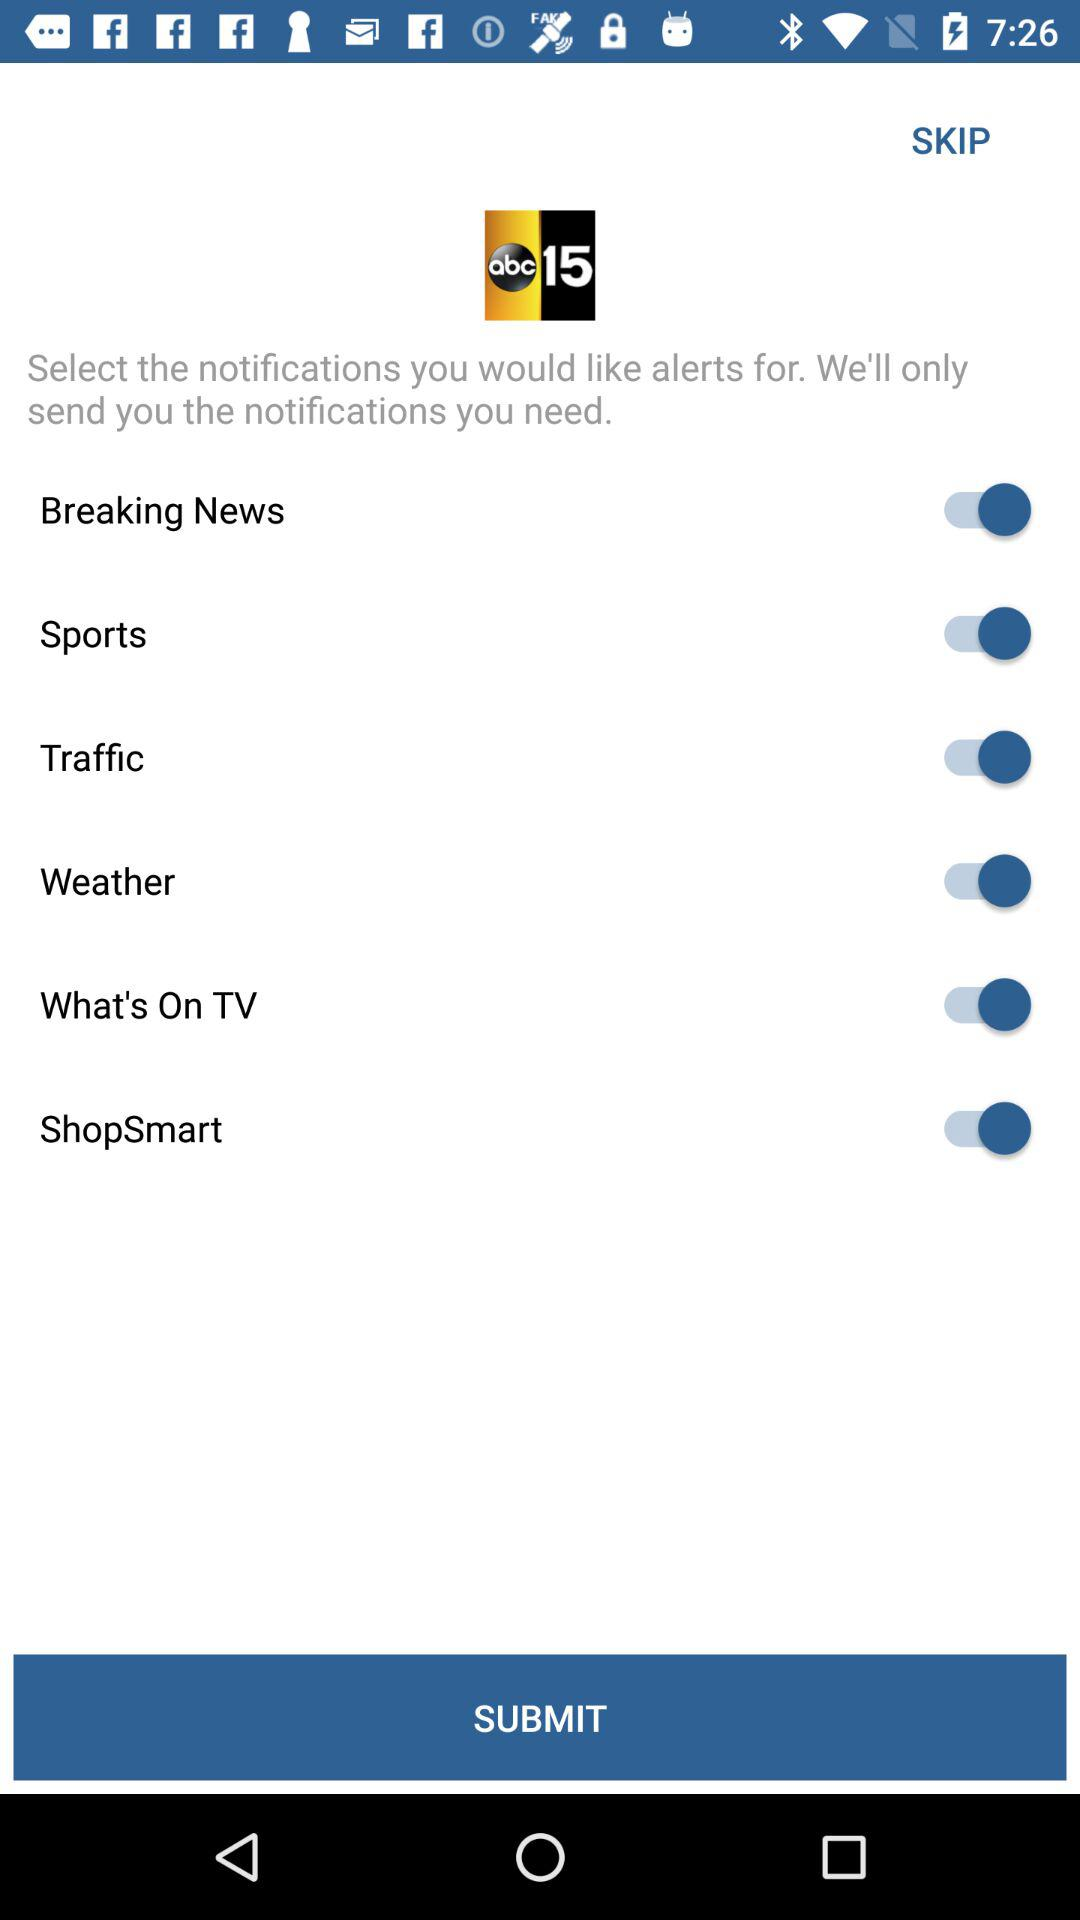What is the status of the "Sports" setting? The status is "on". 